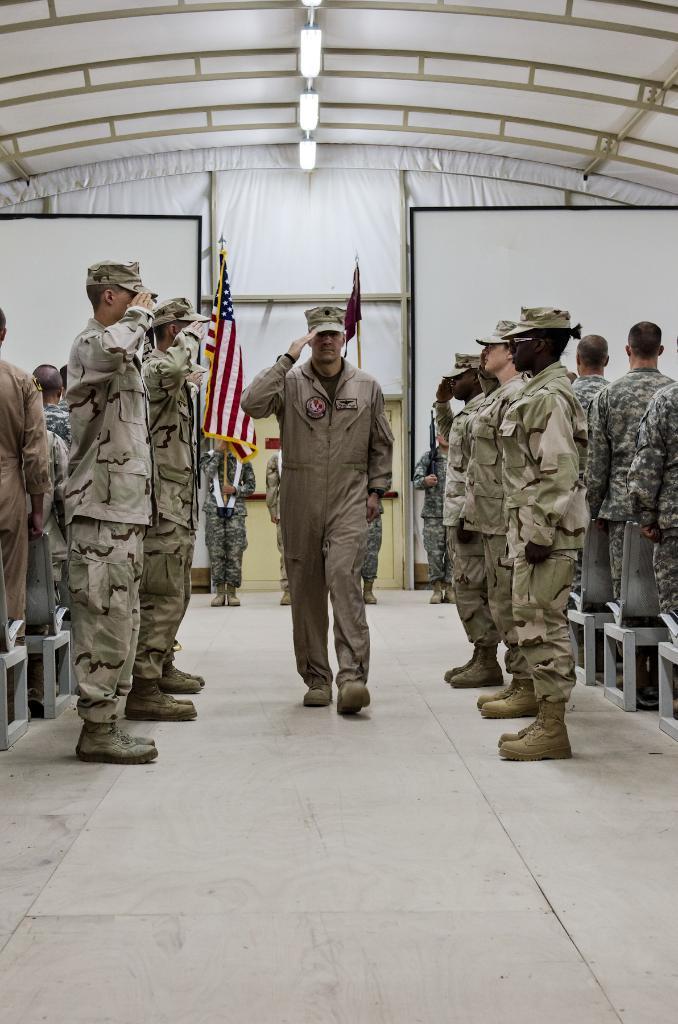Describe this image in one or two sentences. In this image I can see number of people are standing. I can see all of them are wearing uniforms and here I can see few of them are wearing caps. In background I can see few white colour boards, few lights and I can see a person is holding a flag. I can also see one more flag over there. 